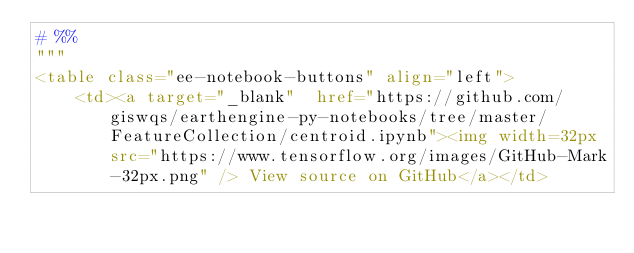Convert code to text. <code><loc_0><loc_0><loc_500><loc_500><_Python_># %%
"""
<table class="ee-notebook-buttons" align="left">
    <td><a target="_blank"  href="https://github.com/giswqs/earthengine-py-notebooks/tree/master/FeatureCollection/centroid.ipynb"><img width=32px src="https://www.tensorflow.org/images/GitHub-Mark-32px.png" /> View source on GitHub</a></td></code> 